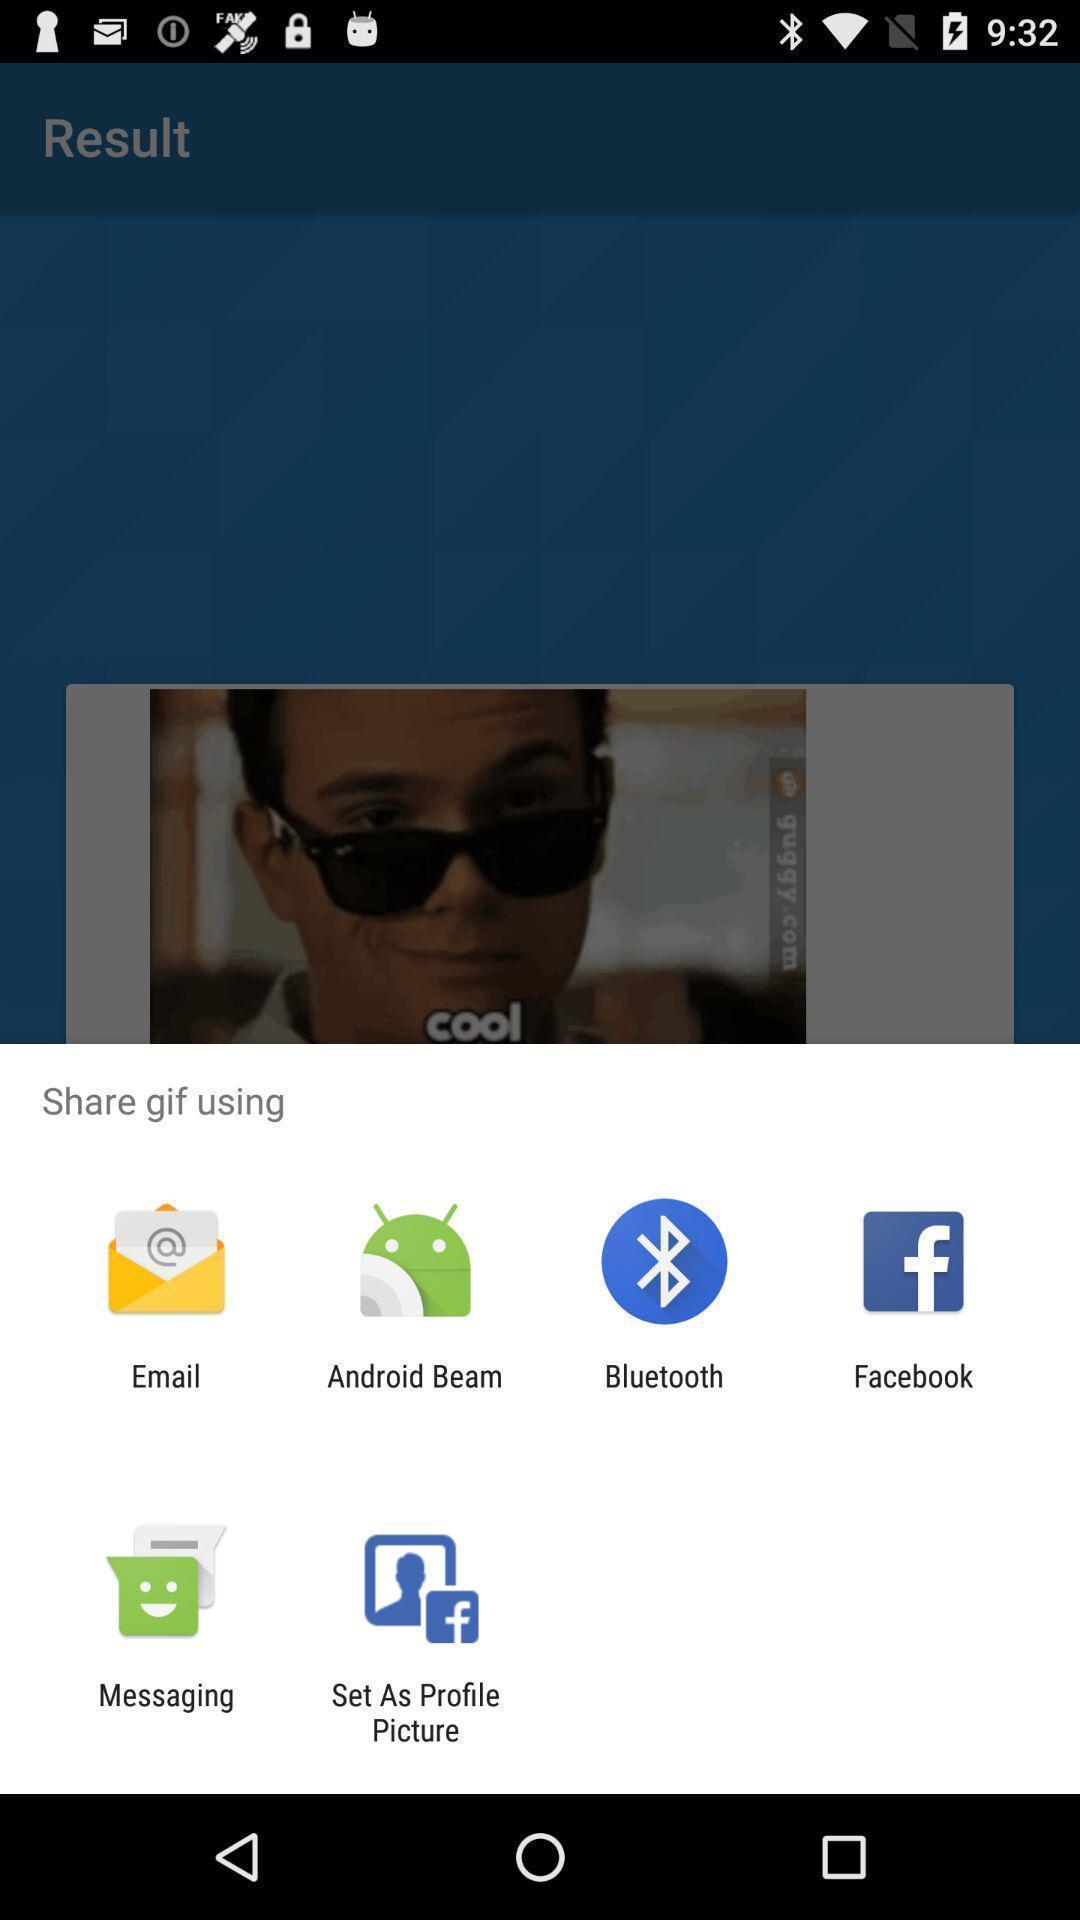What is the overall content of this screenshot? Pop-up showing different sharing options. 